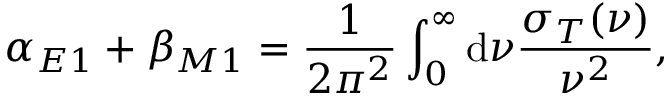<formula> <loc_0><loc_0><loc_500><loc_500>\alpha _ { E 1 } + \beta _ { M 1 } = \frac { 1 } { 2 \pi ^ { 2 } } \int _ { 0 } ^ { \infty } d \nu \frac { \sigma _ { T } ( \nu ) } { \nu ^ { 2 } } ,</formula> 